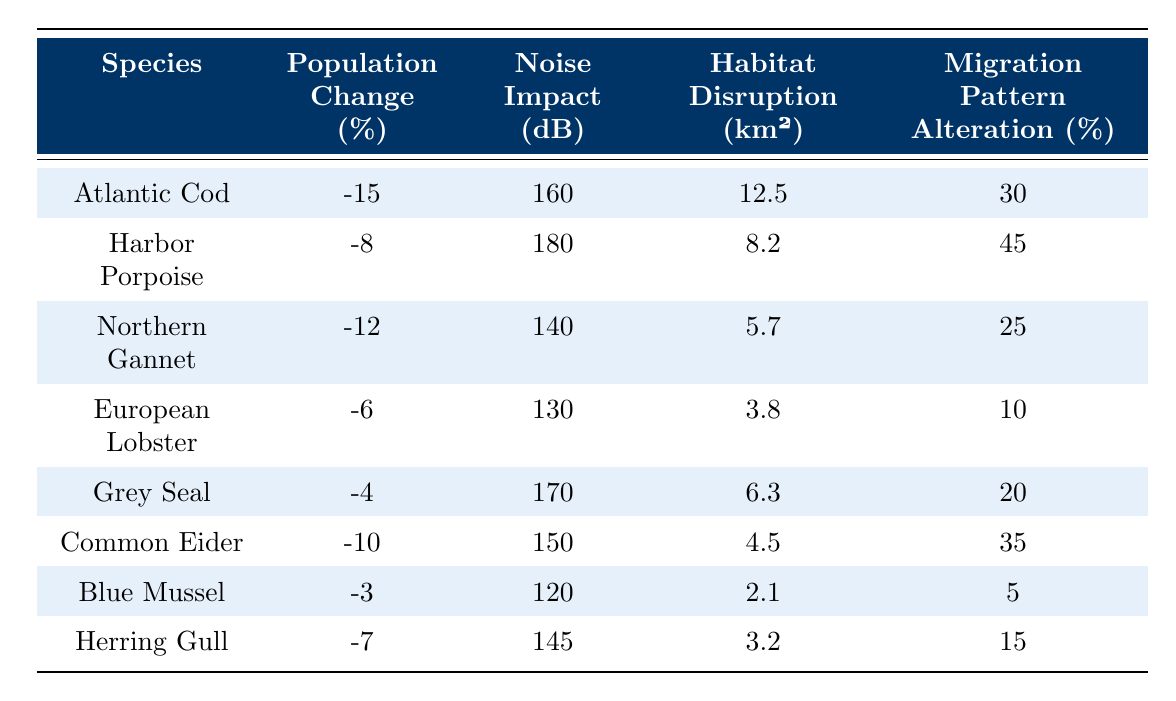What is the population change percentage for the Atlantic Cod? According to the table, the population change percentage for Atlantic Cod is -15%.
Answer: -15% Which species has the highest noise impact? The table shows that the Harbor Porpoise has the highest noise impact of 180 dB.
Answer: 180 dB What is the habitat disruption area for European Lobster? The table indicates that the habitat disruption area for European Lobster is 3.8 km².
Answer: 3.8 km² Which species experiences the lowest percentage change in population? By comparing the population change percentages, Blue Mussel has the lowest change at -3%.
Answer: -3% Is the population change for Grey Seal positive or negative? The table lists the population change for Grey Seal as -4%, which indicates it is negative.
Answer: Negative What is the total habitat disruption for the top three species with the most disruption? The habitat disruption for Atlantic Cod, Harbor Porpoise, and Northern Gannet is 12.5 km², 8.2 km², and 5.7 km² respectively. Summing these gives 12.5 + 8.2 + 5.7 = 26.4 km².
Answer: 26.4 km² Which species shows an alteration in migration patterns greater than 30%? According to the table, both Harbor Porpoise (45%) and Common Eider (35%) show migration pattern alterations greater than 30%.
Answer: Yes What is the average population change for the species listed? To find the average, sum the population changes: -15 - 8 - 12 - 6 - 4 - 10 - 3 - 7 = -65, then divide by the number of species (8). So, -65 / 8 = -8.125%.
Answer: -8.125% Which species has the lowest migration pattern alteration percentage? The Blue Mussel has the lowest migration pattern alteration at 5%.
Answer: 5% If we consider the average noise impact of the listed species, what is the average? The noise impacts are 160, 180, 140, 130, 170, 150, 120, and 145 dB. Summing these gives 1,195 dB, and dividing by 8 species gives an average of 1,195 / 8 = 149.375 dB.
Answer: 149.375 dB 